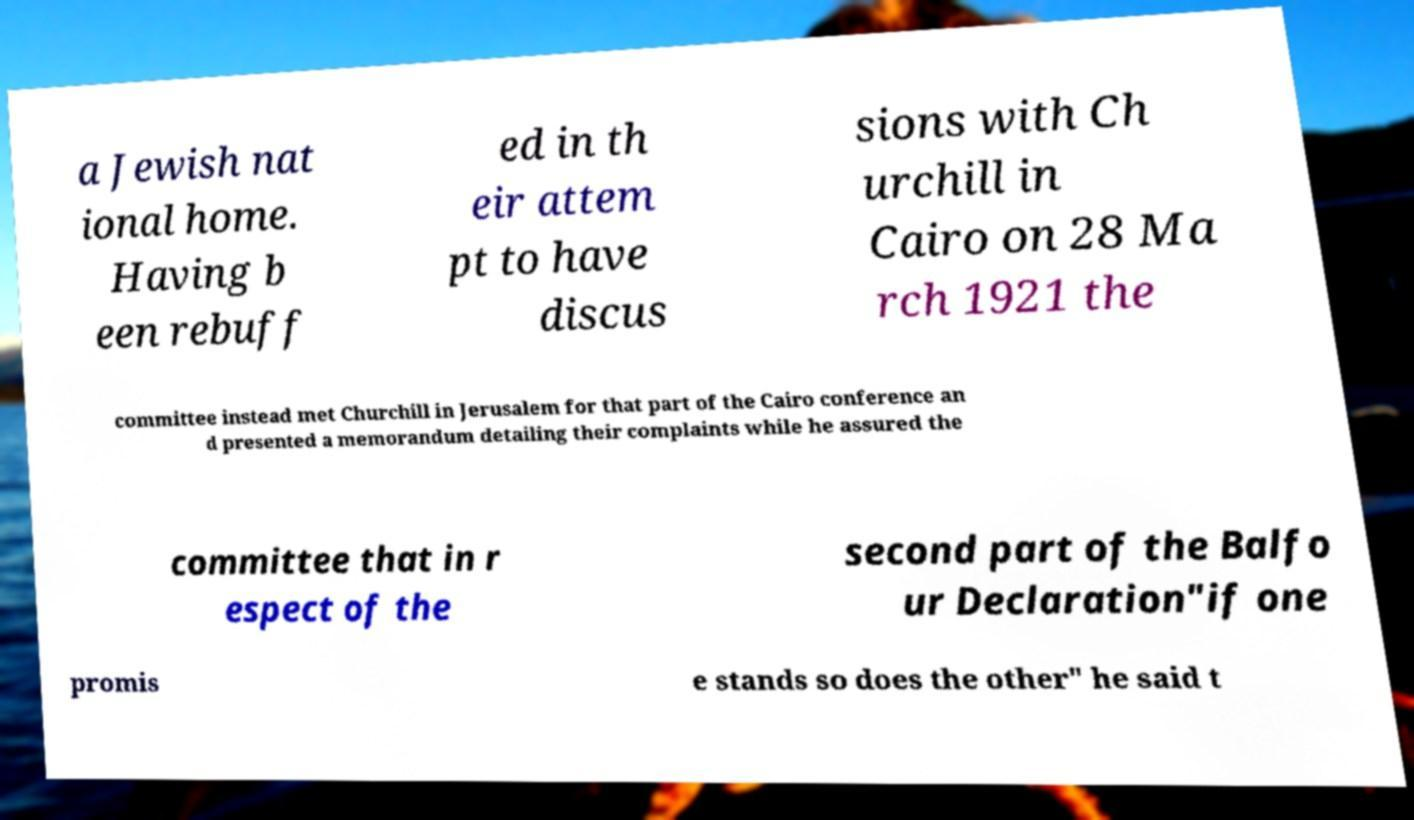Could you assist in decoding the text presented in this image and type it out clearly? a Jewish nat ional home. Having b een rebuff ed in th eir attem pt to have discus sions with Ch urchill in Cairo on 28 Ma rch 1921 the committee instead met Churchill in Jerusalem for that part of the Cairo conference an d presented a memorandum detailing their complaints while he assured the committee that in r espect of the second part of the Balfo ur Declaration"if one promis e stands so does the other" he said t 